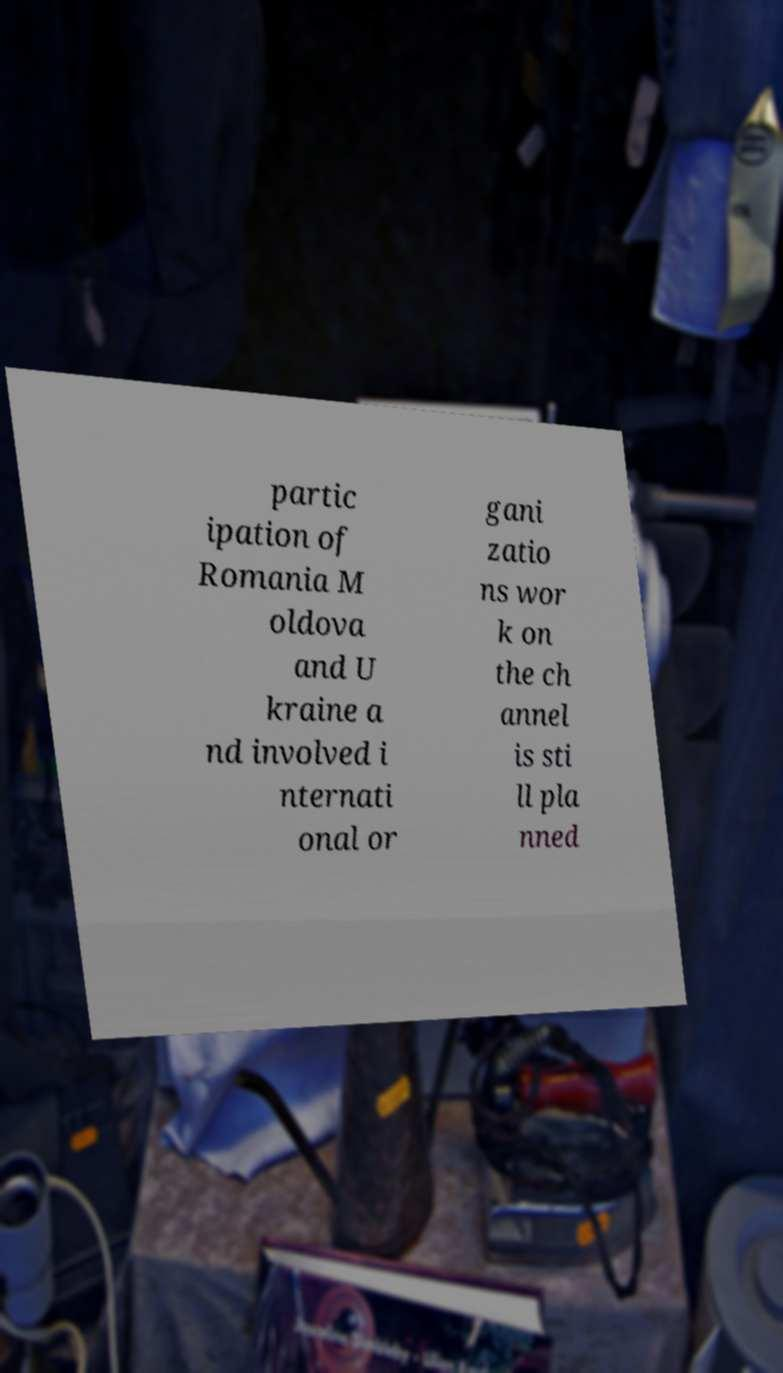Could you assist in decoding the text presented in this image and type it out clearly? partic ipation of Romania M oldova and U kraine a nd involved i nternati onal or gani zatio ns wor k on the ch annel is sti ll pla nned 